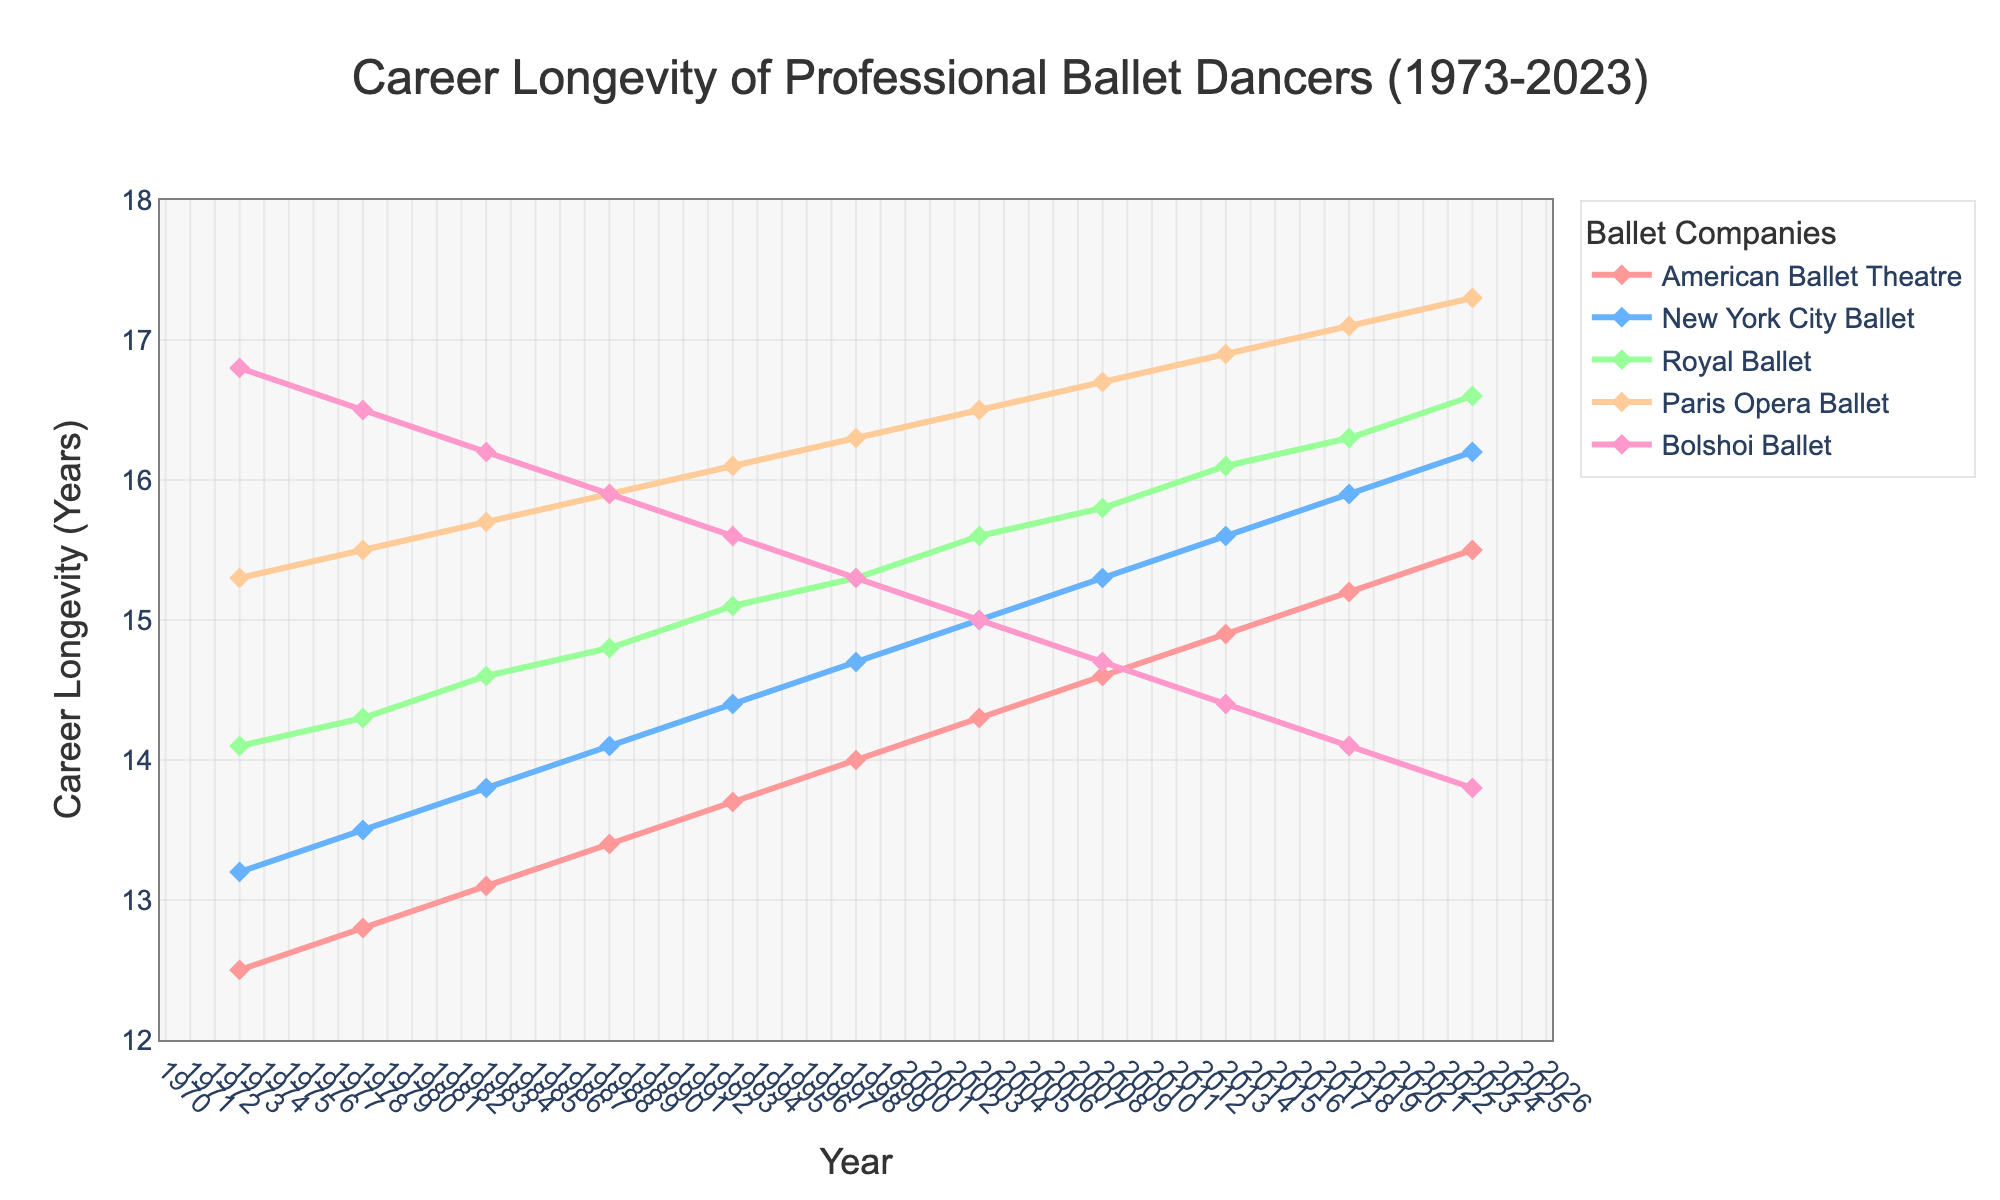What is the overall trend in career longevity for American Ballet Theatre dancers from 1973 to 2023? To identify the trend, trace the line representing American Ballet Theatre from 1973 to 2023 on the chart. The line shows a steady increase in career longevity, from 12.5 years in 1973 to 15.5 years in 2023.
Answer: Increasing Which ballet company had the shortest career longevity in 2023? To determine this, look at the end points of all lines for the year 2023 on the right side of the chart. The Bolshoi Ballet has the lowest point at 13.8 years.
Answer: Bolshoi Ballet How has the career longevity for Paris Opera Ballet changed from 1988 to 2023? Compare the values for Paris Opera Ballet in 1988 and 2023. In 1988, it was 15.9 years, and by 2023, it increased to 17.3 years, showing a rising trend.
Answer: Increased Which two companies had approximately the same career longevity in 1988, and what were their values? Check the values for all companies in 1988. American Ballet Theatre and New York City Ballet had nearly identical values of 13.4 and 14.1 years, respectively. The closest values belong to New York City Ballet and Royal Ballet both having 14.1 and 14.8 years, respectively.
Answer: New York City Ballet and Royal Ballet, 14.1 and 14.8 Between which years did the Bolshoi Ballet see the most significant drop in career longevity? Identify the sharpest decline in the line representing the Bolshoi Ballet. The most significant drop occurs from 2013 (14.4 years) to 2023 (13.8 years).
Answer: 2013 to 2023 What is the average career longevity across all five companies in 2023? Sum the values for all companies in 2023 and divide by the number of companies: (15.5 + 16.2 + 16.6 + 17.3 + 13.8) / 5. The sum is 79.4, and the average is 15.88 years.
Answer: 15.88 years Compare the career longevity of New York City Ballet and Royal Ballet in 1998. Which company had the higher longevity and by how much? Look at the values for New York City Ballet and Royal Ballet in 1998. New York City Ballet had 14.7 years, and Royal Ballet had 15.3 years. Subtracting 14.7 from 15.3 gives 0.6 years.
Answer: Royal Ballet, by 0.6 years What is the maximum career longevity reached by any company over the 50-year span? Scan the chart for the highest point across all lines. Paris Opera Ballet achieves the highest longevity at 17.3 years in 2023.
Answer: 17.3 years What is the difference in career longevity between American Ballet Theatre and Bolshoi Ballet in 1983? Subtract the Bolshoi Ballet's 16.2 years from American Ballet Theatre's 13.1 years in 1983: 16.2 - 13.1 = 3.1 years.
Answer: 3.1 years 